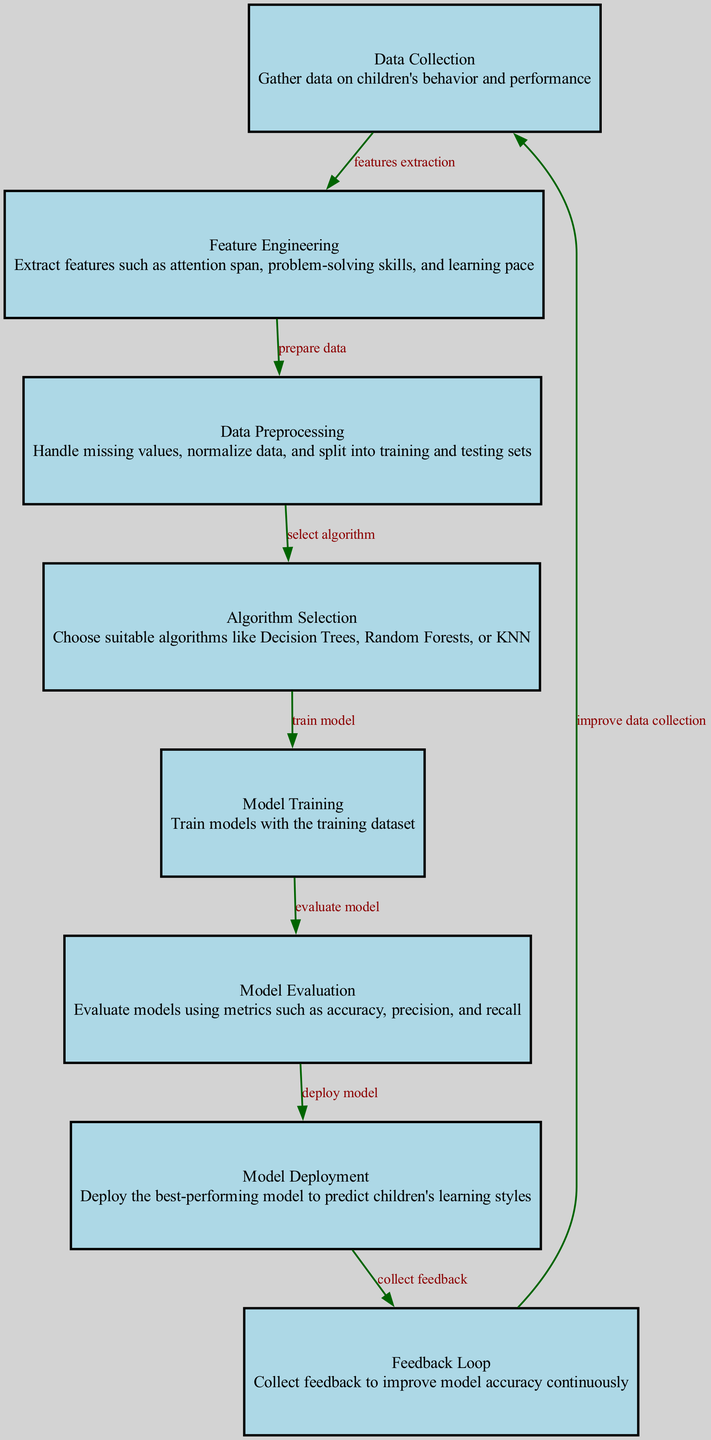What is the first step in the machine learning process? The first step in the diagram is "Data Collection," which involves gathering data on children's behavior and performance. This is clearly indicated as the starting node in the flow.
Answer: Data Collection How many nodes are there in this diagram? By counting the different labeled nodes in the diagram, we find that there are a total of 8 nodes, each representing a specific step in the machine learning process.
Answer: 8 Which algorithm selection is mentioned in the diagram? The diagram indicates that suitable algorithms include Decision Trees, Random Forests, or KNN, capturing the essence of the algorithm selection step.
Answer: Decision Trees, Random Forests, KNN What follows after model evaluation? According to the diagram, after the "Model Evaluation" step, the next step is "Model Deployment." This indicates that once the model is evaluated, it is then deployed.
Answer: Model Deployment Which step collects feedback to improve model accuracy? The "Feedback Loop" step is responsible for collecting feedback, aiming to continually enhance the model's performance based on feedback received from predictions.
Answer: Feedback Loop What is the relationship between data preprocessing and algorithm selection? The relationship is one of progression; "Data Preprocessing" prepares the data which directly leads to "Algorithm Selection," as it sets the stage for choosing the appropriate algorithms.
Answer: select algorithm How do you improve data collection in the cycle? To improve data collection, the final step "Feedback Loop" feeds back into the initial "Data Collection" stage, indicating that insights gained can enhance data gathering methods.
Answer: improve data collection Which model evaluation metrics are mentioned in the diagram? The diagram mentions "accuracy, precision, and recall" as the metrics used for evaluating the models, showcasing a focus on several important aspects of model performance.
Answer: accuracy, precision, recall 